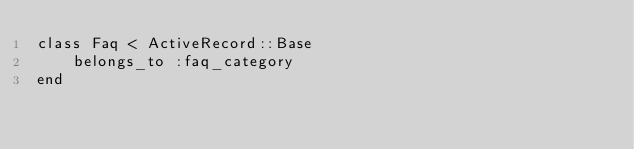Convert code to text. <code><loc_0><loc_0><loc_500><loc_500><_Ruby_>class Faq < ActiveRecord::Base
	belongs_to :faq_category
end
</code> 